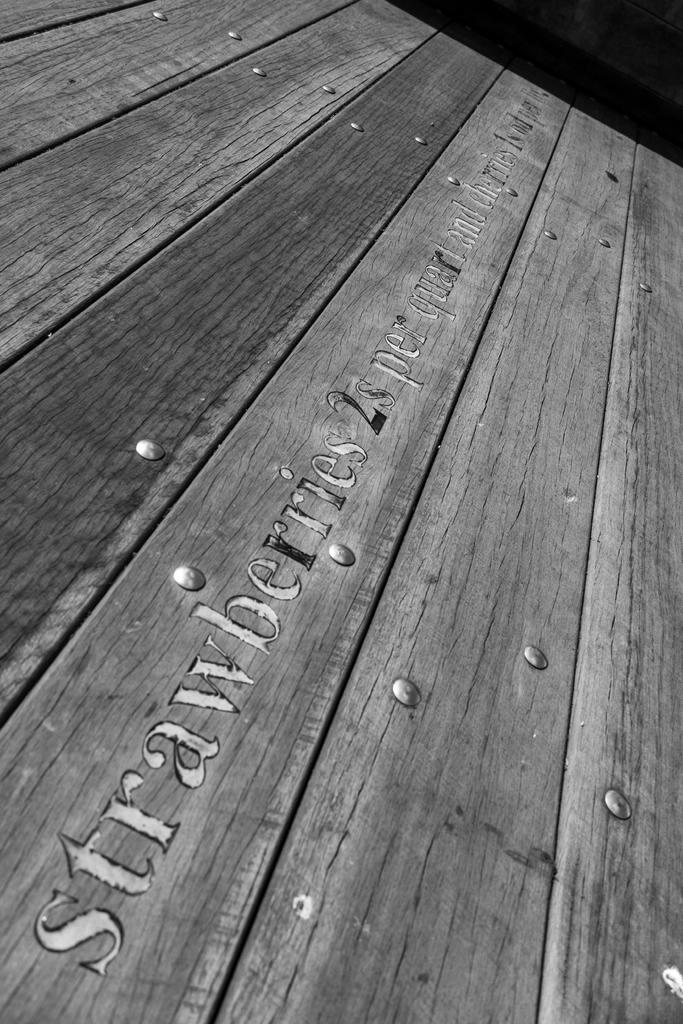What is the color scheme of the image? The image is black and white. What type of furniture is present in the image? There is a table in the image. Is there any text or symbols on the table? Yes, there is writing on the table. Is there a servant standing next to the table in the image? There is no servant present in the image. What type of bait is being used on the guitar in the image? There is no guitar or bait present in the image. 